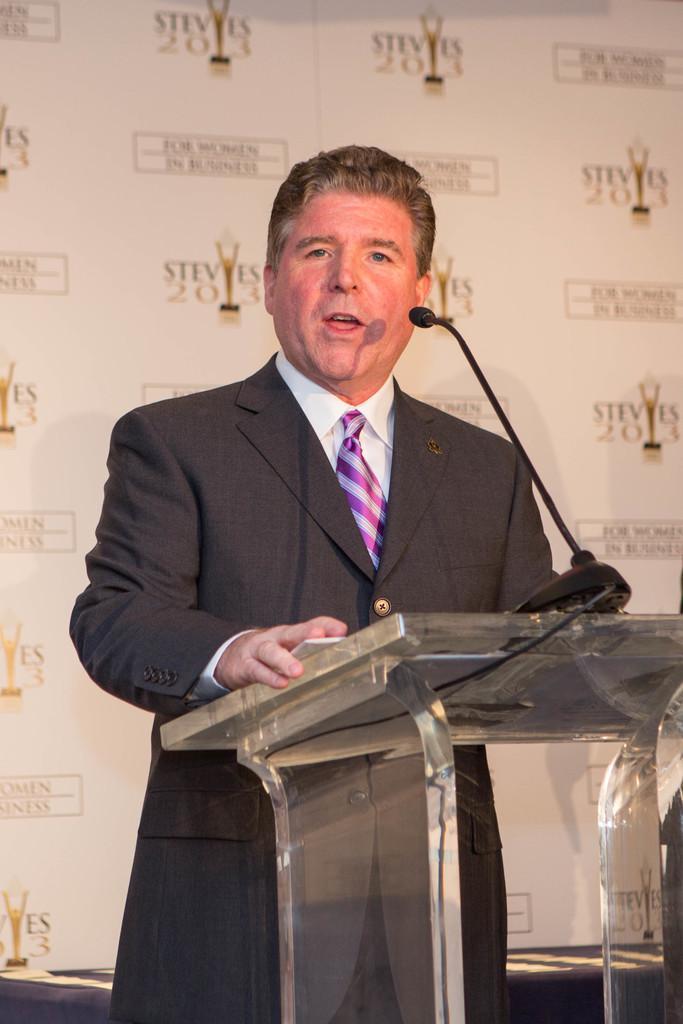Can you describe this image briefly? In this picture i can see a man is standing in front of a podium. On the podium i can see a microphone. The man is wearing suit, shirt and tie. 